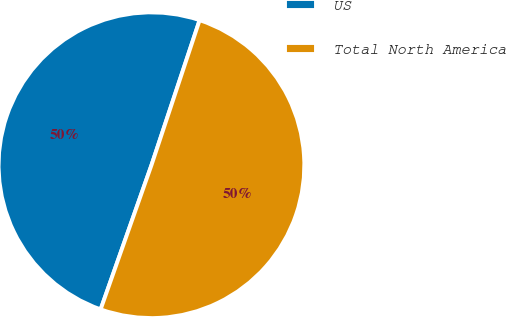Convert chart. <chart><loc_0><loc_0><loc_500><loc_500><pie_chart><fcel>US<fcel>Total North America<nl><fcel>49.71%<fcel>50.29%<nl></chart> 